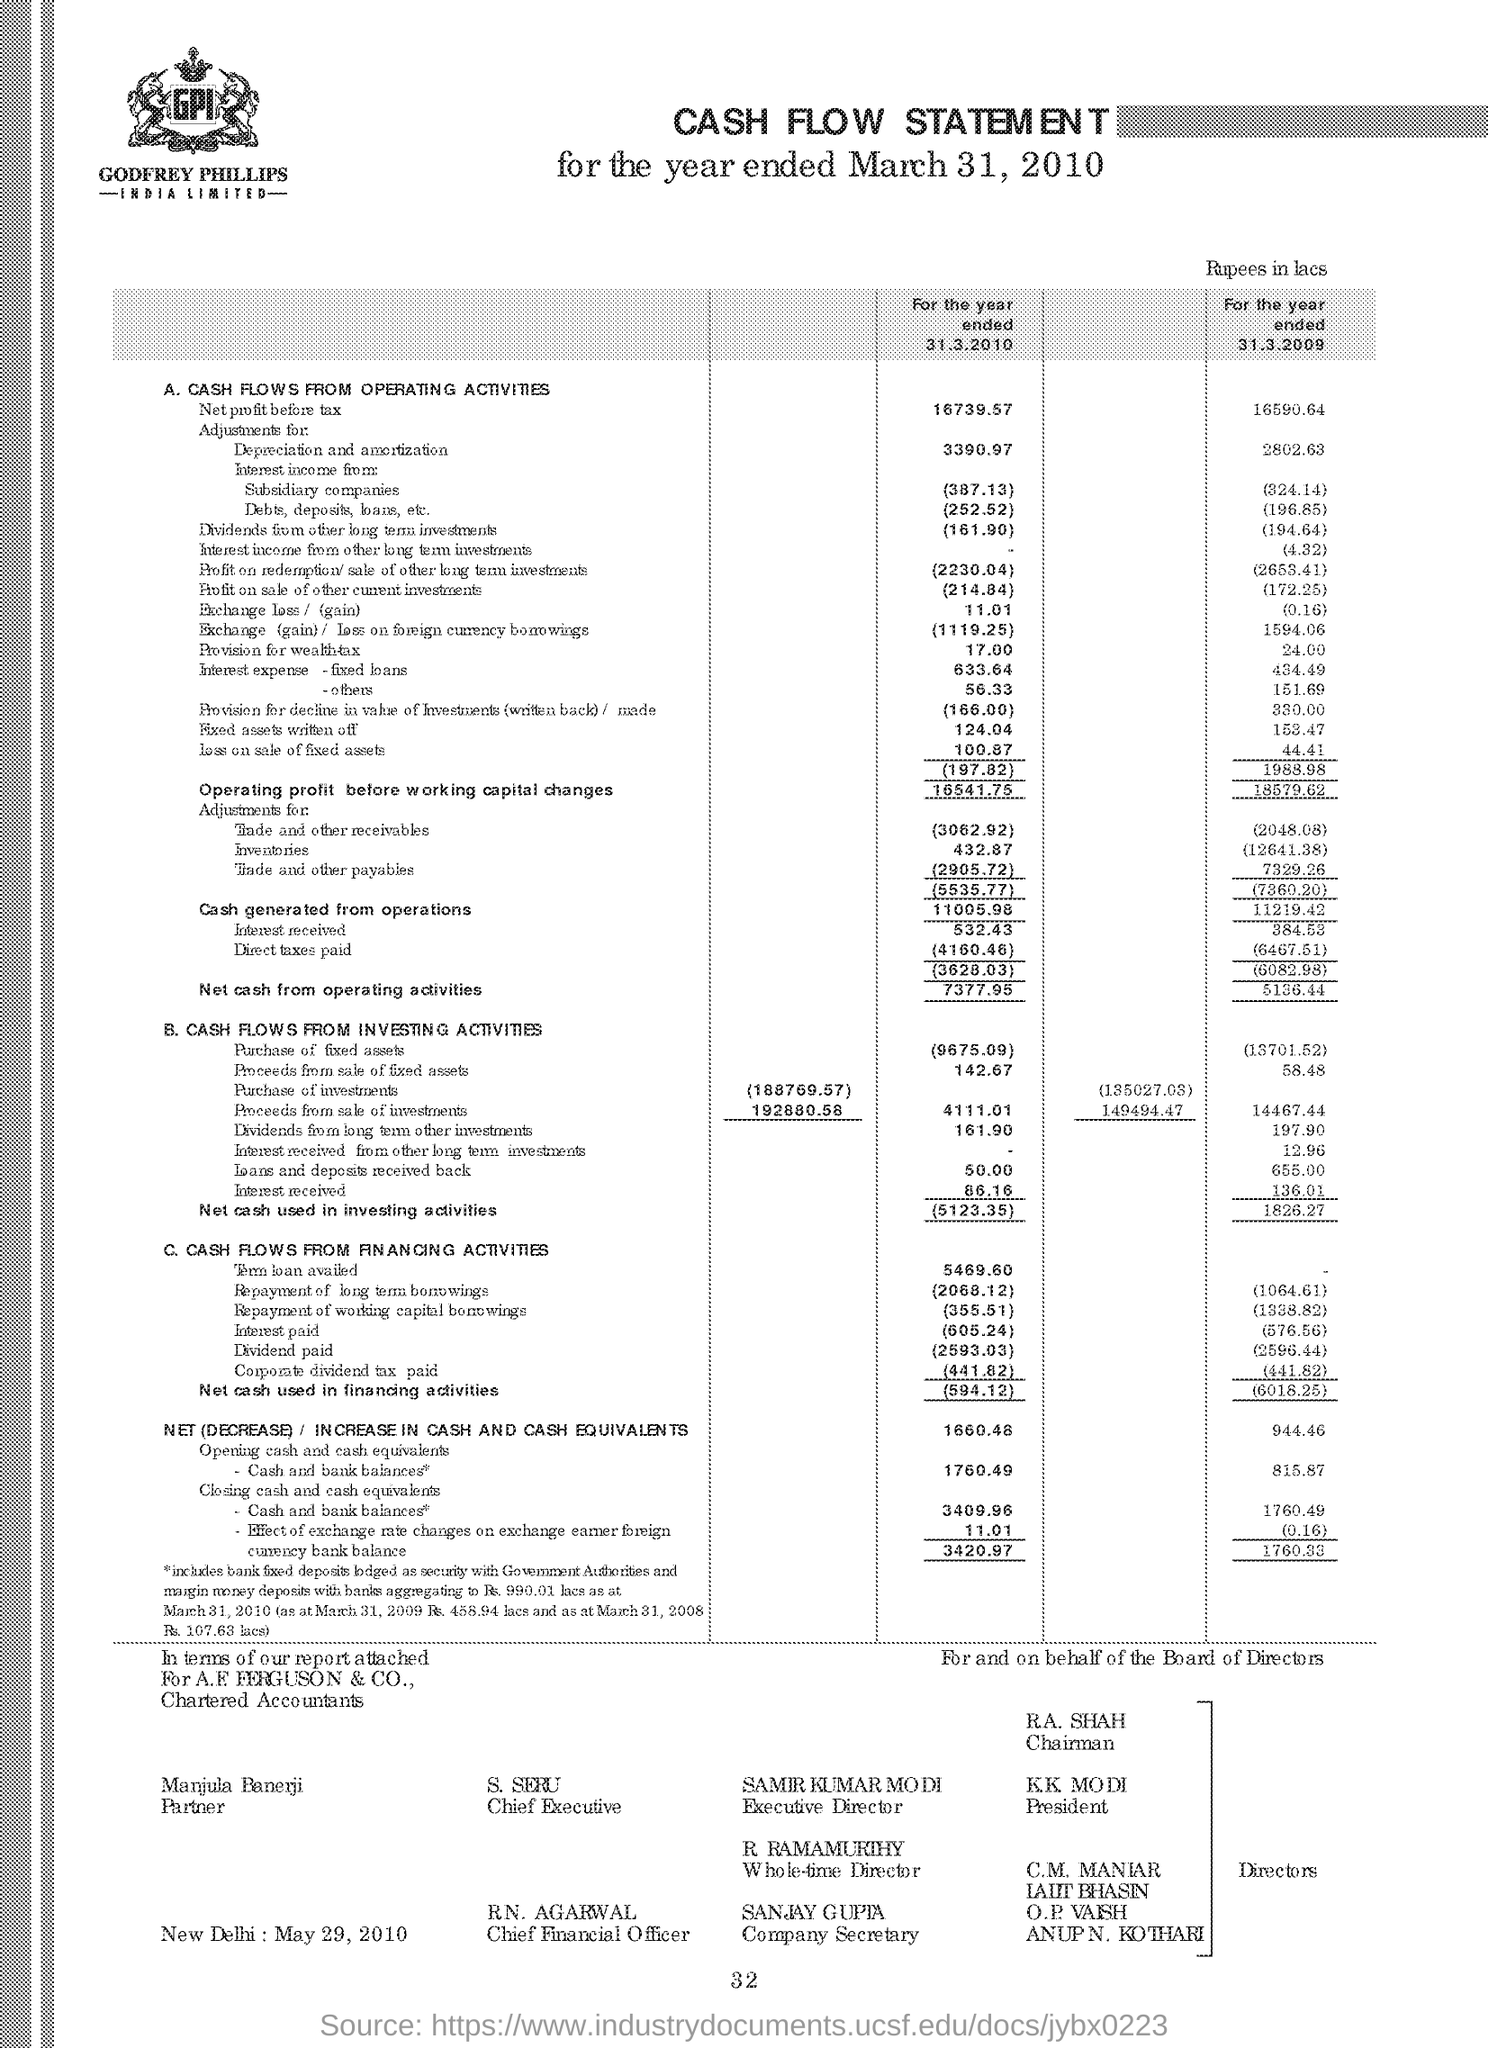What type of document is this?
Your answer should be compact. Cash Flow Statement. Which Chartered Accountants are mentioned?
Provide a short and direct response. A.F. FERGUSON & CO. 